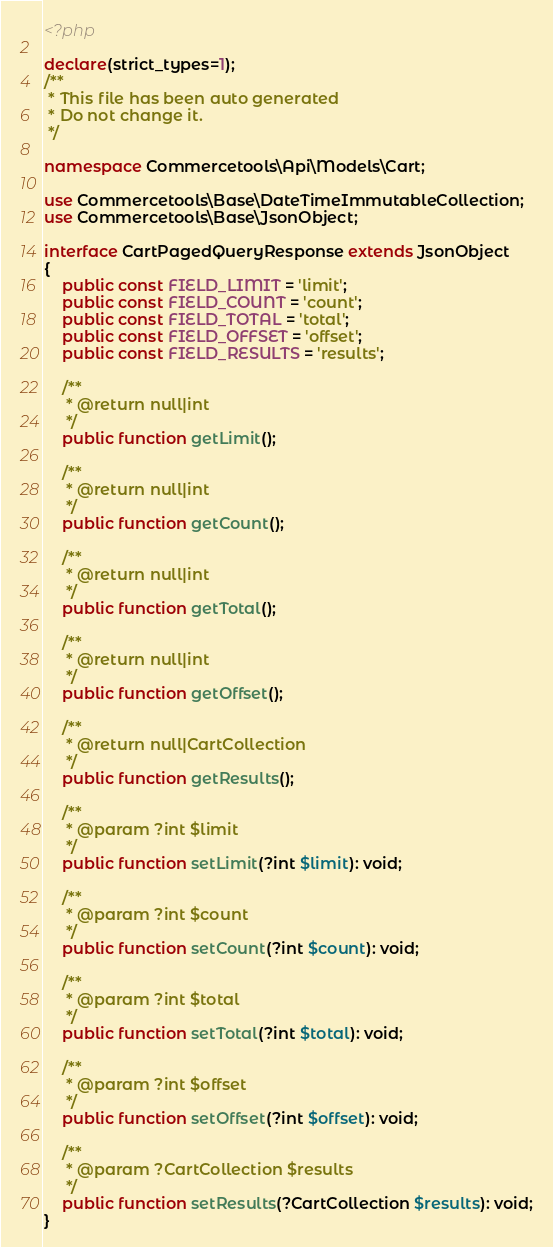<code> <loc_0><loc_0><loc_500><loc_500><_PHP_><?php

declare(strict_types=1);
/**
 * This file has been auto generated
 * Do not change it.
 */

namespace Commercetools\Api\Models\Cart;

use Commercetools\Base\DateTimeImmutableCollection;
use Commercetools\Base\JsonObject;

interface CartPagedQueryResponse extends JsonObject
{
    public const FIELD_LIMIT = 'limit';
    public const FIELD_COUNT = 'count';
    public const FIELD_TOTAL = 'total';
    public const FIELD_OFFSET = 'offset';
    public const FIELD_RESULTS = 'results';

    /**
     * @return null|int
     */
    public function getLimit();

    /**
     * @return null|int
     */
    public function getCount();

    /**
     * @return null|int
     */
    public function getTotal();

    /**
     * @return null|int
     */
    public function getOffset();

    /**
     * @return null|CartCollection
     */
    public function getResults();

    /**
     * @param ?int $limit
     */
    public function setLimit(?int $limit): void;

    /**
     * @param ?int $count
     */
    public function setCount(?int $count): void;

    /**
     * @param ?int $total
     */
    public function setTotal(?int $total): void;

    /**
     * @param ?int $offset
     */
    public function setOffset(?int $offset): void;

    /**
     * @param ?CartCollection $results
     */
    public function setResults(?CartCollection $results): void;
}
</code> 